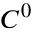<formula> <loc_0><loc_0><loc_500><loc_500>C ^ { 0 }</formula> 